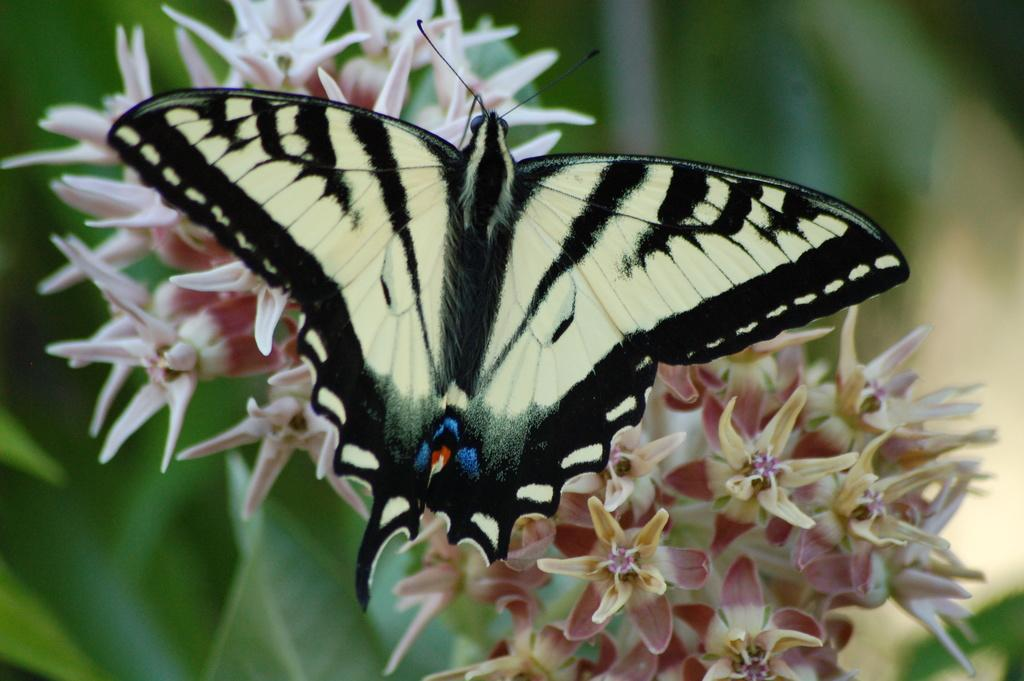What is the main subject of the image? There is a butterfly in the image. Where is the butterfly located in the image? The butterfly is on flowers. What other elements can be seen at the bottom of the image? There are leaves visible at the bottom of the image. Can you describe the background of the image? There is a blurred image in the background of the picture. What is the arm doing in the image? There is no arm present in the image; it features a butterfly on flowers. What type of interest does the butterfly have in the image? The butterfly does not have any specific interests in the image; it is simply resting on flowers. 